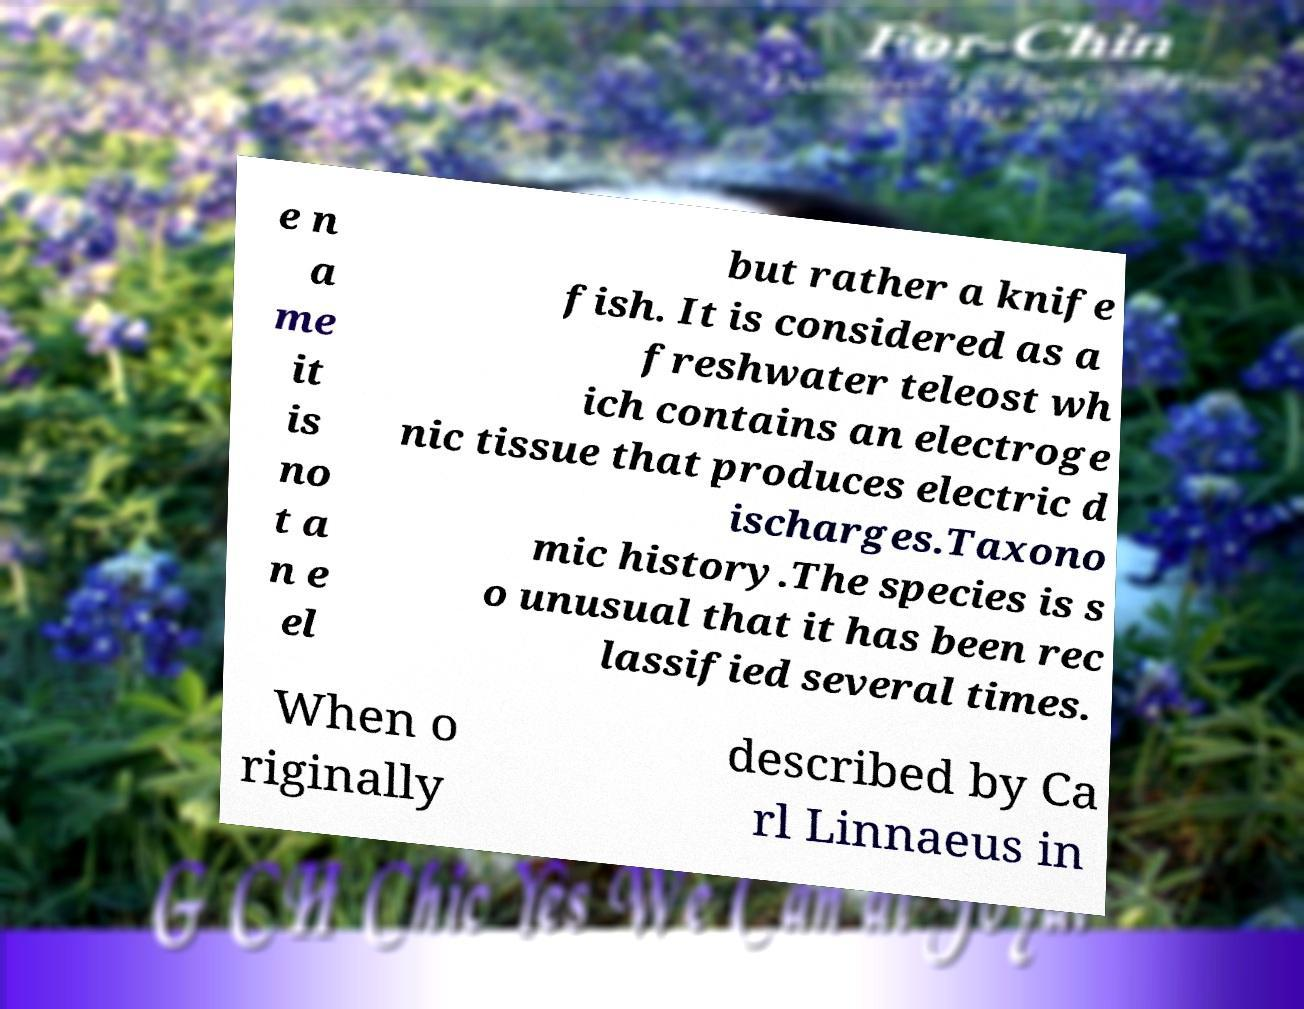There's text embedded in this image that I need extracted. Can you transcribe it verbatim? e n a me it is no t a n e el but rather a knife fish. It is considered as a freshwater teleost wh ich contains an electroge nic tissue that produces electric d ischarges.Taxono mic history.The species is s o unusual that it has been rec lassified several times. When o riginally described by Ca rl Linnaeus in 